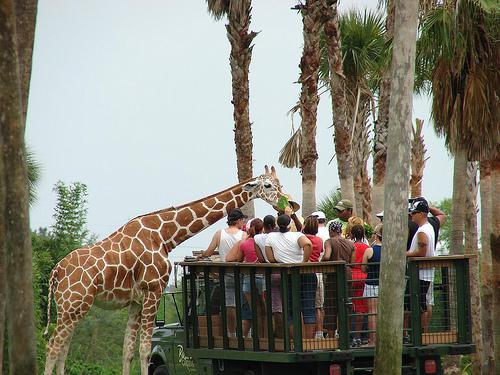Question: why are the people there?
Choices:
A. Safari.
B. The zoo.
C. A reserve.
D. A party.
Answer with the letter. Answer: A Question: what are the people doing?
Choices:
A. Taking pictures.
B. Laughing at the giraffe.
C. Feeding the giraffe.
D. Blinking at the giraffe.
Answer with the letter. Answer: C Question: what is surrounding the people?
Choices:
A. Trees.
B. Lights.
C. Furniture.
D. Flowers.
Answer with the letter. Answer: A Question: what is the giraffe doing?
Choices:
A. Eating.
B. Drinking.
C. Running.
D. Mating.
Answer with the letter. Answer: A Question: what is on the giraffe's head?
Choices:
A. Horns.
B. Ears.
C. Spots.
D. Hair.
Answer with the letter. Answer: A 